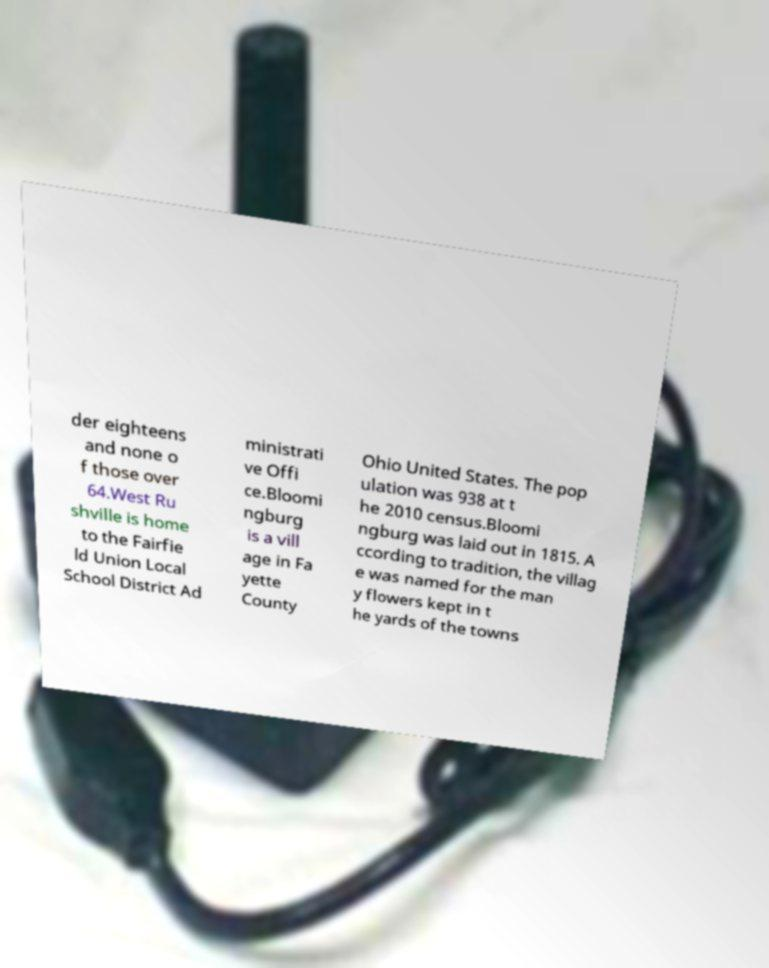Please identify and transcribe the text found in this image. der eighteens and none o f those over 64.West Ru shville is home to the Fairfie ld Union Local School District Ad ministrati ve Offi ce.Bloomi ngburg is a vill age in Fa yette County Ohio United States. The pop ulation was 938 at t he 2010 census.Bloomi ngburg was laid out in 1815. A ccording to tradition, the villag e was named for the man y flowers kept in t he yards of the towns 